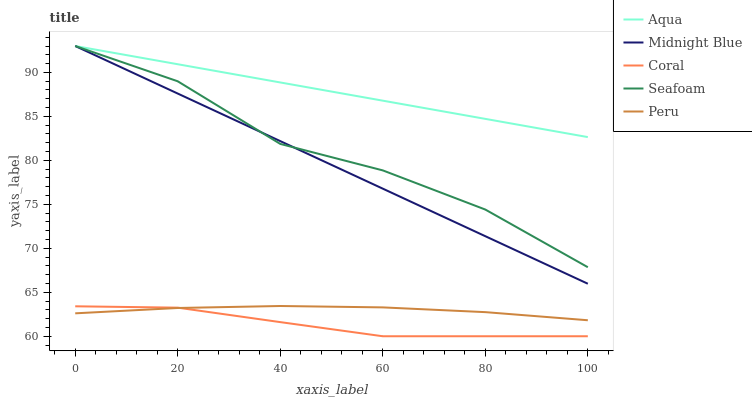Does Coral have the minimum area under the curve?
Answer yes or no. Yes. Does Aqua have the maximum area under the curve?
Answer yes or no. Yes. Does Midnight Blue have the minimum area under the curve?
Answer yes or no. No. Does Midnight Blue have the maximum area under the curve?
Answer yes or no. No. Is Midnight Blue the smoothest?
Answer yes or no. Yes. Is Seafoam the roughest?
Answer yes or no. Yes. Is Aqua the smoothest?
Answer yes or no. No. Is Aqua the roughest?
Answer yes or no. No. Does Midnight Blue have the lowest value?
Answer yes or no. No. Does Seafoam have the highest value?
Answer yes or no. Yes. Does Peru have the highest value?
Answer yes or no. No. Is Coral less than Aqua?
Answer yes or no. Yes. Is Seafoam greater than Peru?
Answer yes or no. Yes. Does Seafoam intersect Midnight Blue?
Answer yes or no. Yes. Is Seafoam less than Midnight Blue?
Answer yes or no. No. Is Seafoam greater than Midnight Blue?
Answer yes or no. No. Does Coral intersect Aqua?
Answer yes or no. No. 